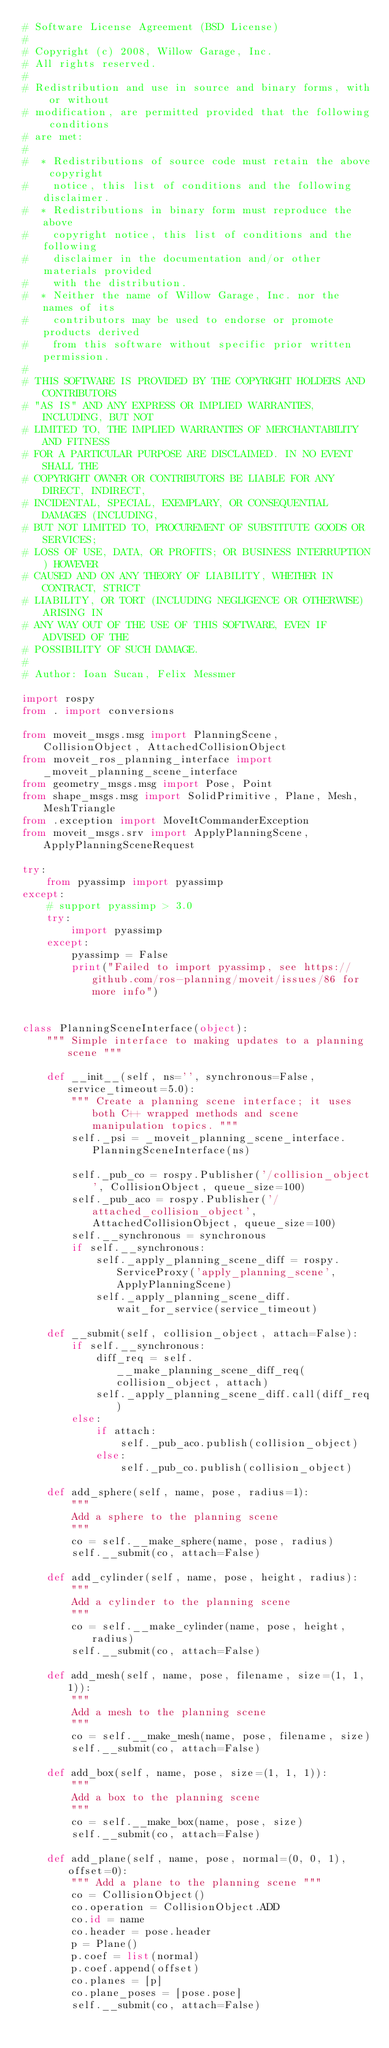<code> <loc_0><loc_0><loc_500><loc_500><_Python_># Software License Agreement (BSD License)
#
# Copyright (c) 2008, Willow Garage, Inc.
# All rights reserved.
#
# Redistribution and use in source and binary forms, with or without
# modification, are permitted provided that the following conditions
# are met:
#
#  * Redistributions of source code must retain the above copyright
#    notice, this list of conditions and the following disclaimer.
#  * Redistributions in binary form must reproduce the above
#    copyright notice, this list of conditions and the following
#    disclaimer in the documentation and/or other materials provided
#    with the distribution.
#  * Neither the name of Willow Garage, Inc. nor the names of its
#    contributors may be used to endorse or promote products derived
#    from this software without specific prior written permission.
#
# THIS SOFTWARE IS PROVIDED BY THE COPYRIGHT HOLDERS AND CONTRIBUTORS
# "AS IS" AND ANY EXPRESS OR IMPLIED WARRANTIES, INCLUDING, BUT NOT
# LIMITED TO, THE IMPLIED WARRANTIES OF MERCHANTABILITY AND FITNESS
# FOR A PARTICULAR PURPOSE ARE DISCLAIMED. IN NO EVENT SHALL THE
# COPYRIGHT OWNER OR CONTRIBUTORS BE LIABLE FOR ANY DIRECT, INDIRECT,
# INCIDENTAL, SPECIAL, EXEMPLARY, OR CONSEQUENTIAL DAMAGES (INCLUDING,
# BUT NOT LIMITED TO, PROCUREMENT OF SUBSTITUTE GOODS OR SERVICES;
# LOSS OF USE, DATA, OR PROFITS; OR BUSINESS INTERRUPTION) HOWEVER
# CAUSED AND ON ANY THEORY OF LIABILITY, WHETHER IN CONTRACT, STRICT
# LIABILITY, OR TORT (INCLUDING NEGLIGENCE OR OTHERWISE) ARISING IN
# ANY WAY OUT OF THE USE OF THIS SOFTWARE, EVEN IF ADVISED OF THE
# POSSIBILITY OF SUCH DAMAGE.
#
# Author: Ioan Sucan, Felix Messmer

import rospy
from . import conversions

from moveit_msgs.msg import PlanningScene, CollisionObject, AttachedCollisionObject
from moveit_ros_planning_interface import _moveit_planning_scene_interface
from geometry_msgs.msg import Pose, Point
from shape_msgs.msg import SolidPrimitive, Plane, Mesh, MeshTriangle
from .exception import MoveItCommanderException
from moveit_msgs.srv import ApplyPlanningScene, ApplyPlanningSceneRequest

try:
    from pyassimp import pyassimp
except:
    # support pyassimp > 3.0
    try:
        import pyassimp
    except:
        pyassimp = False
        print("Failed to import pyassimp, see https://github.com/ros-planning/moveit/issues/86 for more info")


class PlanningSceneInterface(object):
    """ Simple interface to making updates to a planning scene """

    def __init__(self, ns='', synchronous=False, service_timeout=5.0):
        """ Create a planning scene interface; it uses both C++ wrapped methods and scene manipulation topics. """
        self._psi = _moveit_planning_scene_interface.PlanningSceneInterface(ns)

        self._pub_co = rospy.Publisher('/collision_object', CollisionObject, queue_size=100)
        self._pub_aco = rospy.Publisher('/attached_collision_object', AttachedCollisionObject, queue_size=100)
        self.__synchronous = synchronous
        if self.__synchronous:
            self._apply_planning_scene_diff = rospy.ServiceProxy('apply_planning_scene', ApplyPlanningScene)
            self._apply_planning_scene_diff.wait_for_service(service_timeout)

    def __submit(self, collision_object, attach=False):
        if self.__synchronous:
            diff_req = self.__make_planning_scene_diff_req(collision_object, attach)
            self._apply_planning_scene_diff.call(diff_req)
        else:
            if attach:
                self._pub_aco.publish(collision_object)
            else:
                self._pub_co.publish(collision_object)

    def add_sphere(self, name, pose, radius=1):
        """
        Add a sphere to the planning scene
        """
        co = self.__make_sphere(name, pose, radius)
        self.__submit(co, attach=False)

    def add_cylinder(self, name, pose, height, radius):
        """
        Add a cylinder to the planning scene
        """
        co = self.__make_cylinder(name, pose, height, radius)
        self.__submit(co, attach=False)

    def add_mesh(self, name, pose, filename, size=(1, 1, 1)):
        """
        Add a mesh to the planning scene
        """
        co = self.__make_mesh(name, pose, filename, size)
        self.__submit(co, attach=False)

    def add_box(self, name, pose, size=(1, 1, 1)):
        """
        Add a box to the planning scene
        """
        co = self.__make_box(name, pose, size)
        self.__submit(co, attach=False)

    def add_plane(self, name, pose, normal=(0, 0, 1), offset=0):
        """ Add a plane to the planning scene """
        co = CollisionObject()
        co.operation = CollisionObject.ADD
        co.id = name
        co.header = pose.header
        p = Plane()
        p.coef = list(normal)
        p.coef.append(offset)
        co.planes = [p]
        co.plane_poses = [pose.pose]
        self.__submit(co, attach=False)
</code> 